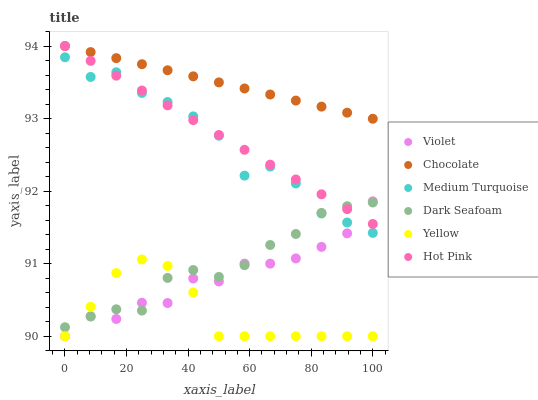Does Yellow have the minimum area under the curve?
Answer yes or no. Yes. Does Chocolate have the maximum area under the curve?
Answer yes or no. Yes. Does Chocolate have the minimum area under the curve?
Answer yes or no. No. Does Yellow have the maximum area under the curve?
Answer yes or no. No. Is Chocolate the smoothest?
Answer yes or no. Yes. Is Medium Turquoise the roughest?
Answer yes or no. Yes. Is Yellow the smoothest?
Answer yes or no. No. Is Yellow the roughest?
Answer yes or no. No. Does Yellow have the lowest value?
Answer yes or no. Yes. Does Chocolate have the lowest value?
Answer yes or no. No. Does Chocolate have the highest value?
Answer yes or no. Yes. Does Yellow have the highest value?
Answer yes or no. No. Is Violet less than Chocolate?
Answer yes or no. Yes. Is Medium Turquoise greater than Yellow?
Answer yes or no. Yes. Does Dark Seafoam intersect Medium Turquoise?
Answer yes or no. Yes. Is Dark Seafoam less than Medium Turquoise?
Answer yes or no. No. Is Dark Seafoam greater than Medium Turquoise?
Answer yes or no. No. Does Violet intersect Chocolate?
Answer yes or no. No. 